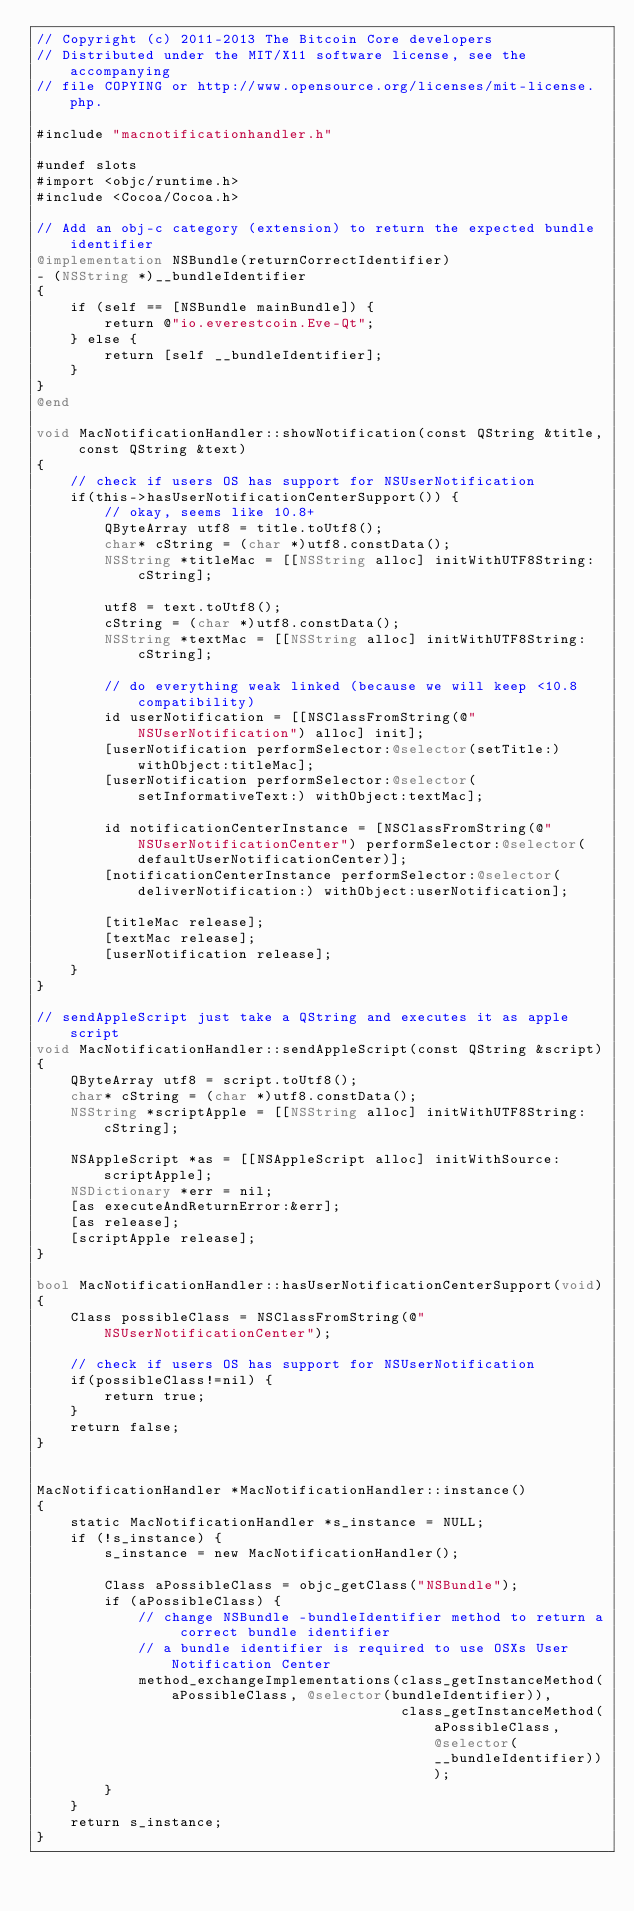<code> <loc_0><loc_0><loc_500><loc_500><_ObjectiveC_>// Copyright (c) 2011-2013 The Bitcoin Core developers
// Distributed under the MIT/X11 software license, see the accompanying
// file COPYING or http://www.opensource.org/licenses/mit-license.php.

#include "macnotificationhandler.h"

#undef slots
#import <objc/runtime.h>
#include <Cocoa/Cocoa.h>

// Add an obj-c category (extension) to return the expected bundle identifier
@implementation NSBundle(returnCorrectIdentifier)
- (NSString *)__bundleIdentifier
{
    if (self == [NSBundle mainBundle]) {
        return @"io.everestcoin.Eve-Qt";
    } else {
        return [self __bundleIdentifier];
    }
}
@end

void MacNotificationHandler::showNotification(const QString &title, const QString &text)
{
    // check if users OS has support for NSUserNotification
    if(this->hasUserNotificationCenterSupport()) {
        // okay, seems like 10.8+
        QByteArray utf8 = title.toUtf8();
        char* cString = (char *)utf8.constData();
        NSString *titleMac = [[NSString alloc] initWithUTF8String:cString];

        utf8 = text.toUtf8();
        cString = (char *)utf8.constData();
        NSString *textMac = [[NSString alloc] initWithUTF8String:cString];

        // do everything weak linked (because we will keep <10.8 compatibility)
        id userNotification = [[NSClassFromString(@"NSUserNotification") alloc] init];
        [userNotification performSelector:@selector(setTitle:) withObject:titleMac];
        [userNotification performSelector:@selector(setInformativeText:) withObject:textMac];

        id notificationCenterInstance = [NSClassFromString(@"NSUserNotificationCenter") performSelector:@selector(defaultUserNotificationCenter)];
        [notificationCenterInstance performSelector:@selector(deliverNotification:) withObject:userNotification];

        [titleMac release];
        [textMac release];
        [userNotification release];
    }
}

// sendAppleScript just take a QString and executes it as apple script
void MacNotificationHandler::sendAppleScript(const QString &script)
{
    QByteArray utf8 = script.toUtf8();
    char* cString = (char *)utf8.constData();
    NSString *scriptApple = [[NSString alloc] initWithUTF8String:cString];

    NSAppleScript *as = [[NSAppleScript alloc] initWithSource:scriptApple];
    NSDictionary *err = nil;
    [as executeAndReturnError:&err];
    [as release];
    [scriptApple release];
}

bool MacNotificationHandler::hasUserNotificationCenterSupport(void)
{
    Class possibleClass = NSClassFromString(@"NSUserNotificationCenter");

    // check if users OS has support for NSUserNotification
    if(possibleClass!=nil) {
        return true;
    }
    return false;
}


MacNotificationHandler *MacNotificationHandler::instance()
{
    static MacNotificationHandler *s_instance = NULL;
    if (!s_instance) {
        s_instance = new MacNotificationHandler();
        
        Class aPossibleClass = objc_getClass("NSBundle");
        if (aPossibleClass) {
            // change NSBundle -bundleIdentifier method to return a correct bundle identifier
            // a bundle identifier is required to use OSXs User Notification Center
            method_exchangeImplementations(class_getInstanceMethod(aPossibleClass, @selector(bundleIdentifier)),
                                           class_getInstanceMethod(aPossibleClass, @selector(__bundleIdentifier)));
        }
    }
    return s_instance;
}
</code> 